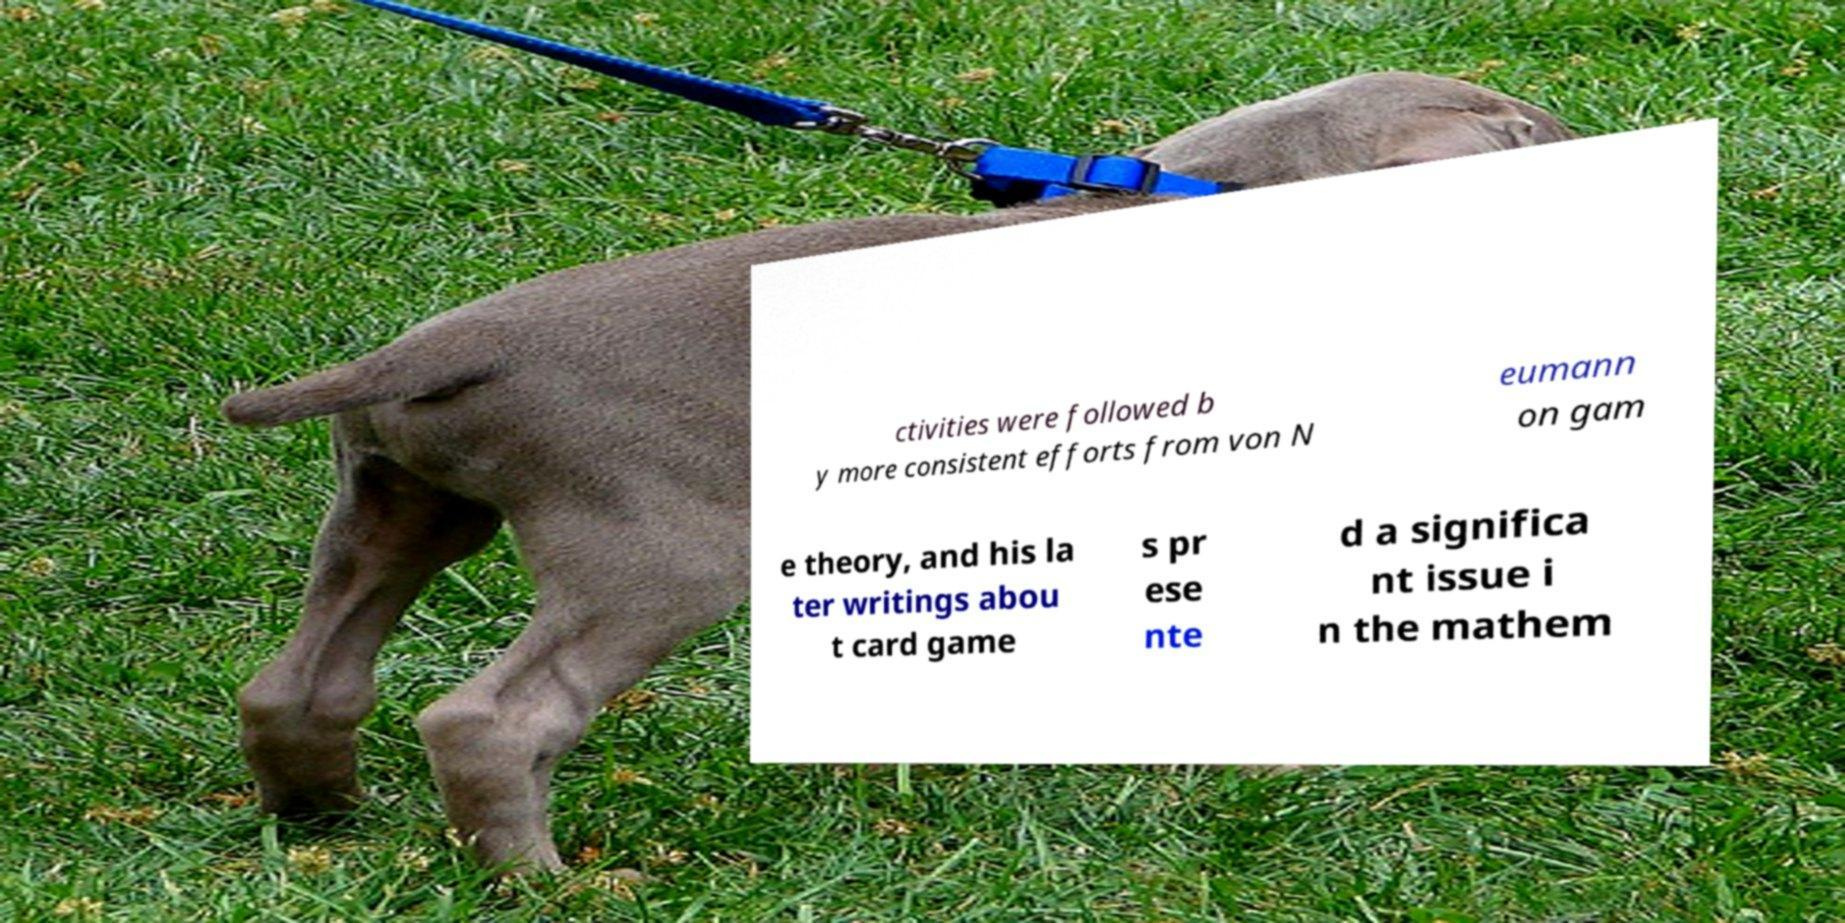Can you accurately transcribe the text from the provided image for me? ctivities were followed b y more consistent efforts from von N eumann on gam e theory, and his la ter writings abou t card game s pr ese nte d a significa nt issue i n the mathem 